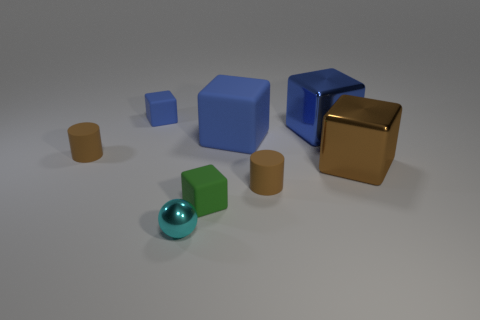How many blue blocks must be subtracted to get 1 blue blocks? 2 Subtract all tiny cubes. How many cubes are left? 3 Add 1 matte cylinders. How many objects exist? 9 Subtract all brown blocks. How many blocks are left? 4 Subtract 2 cylinders. How many cylinders are left? 0 Subtract all green cylinders. Subtract all purple cubes. How many cylinders are left? 2 Subtract all purple cylinders. How many blue blocks are left? 3 Subtract all large blue matte objects. Subtract all blue rubber cubes. How many objects are left? 5 Add 7 brown blocks. How many brown blocks are left? 8 Add 5 tiny objects. How many tiny objects exist? 10 